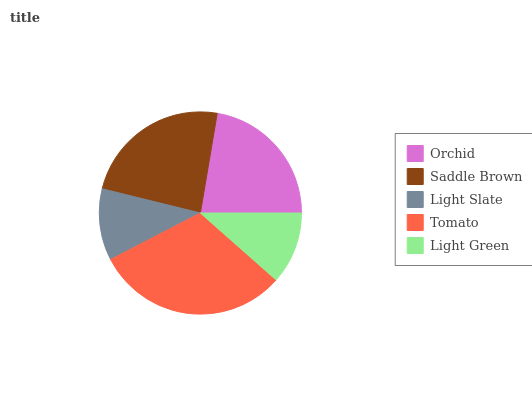Is Light Slate the minimum?
Answer yes or no. Yes. Is Tomato the maximum?
Answer yes or no. Yes. Is Saddle Brown the minimum?
Answer yes or no. No. Is Saddle Brown the maximum?
Answer yes or no. No. Is Saddle Brown greater than Orchid?
Answer yes or no. Yes. Is Orchid less than Saddle Brown?
Answer yes or no. Yes. Is Orchid greater than Saddle Brown?
Answer yes or no. No. Is Saddle Brown less than Orchid?
Answer yes or no. No. Is Orchid the high median?
Answer yes or no. Yes. Is Orchid the low median?
Answer yes or no. Yes. Is Light Slate the high median?
Answer yes or no. No. Is Saddle Brown the low median?
Answer yes or no. No. 